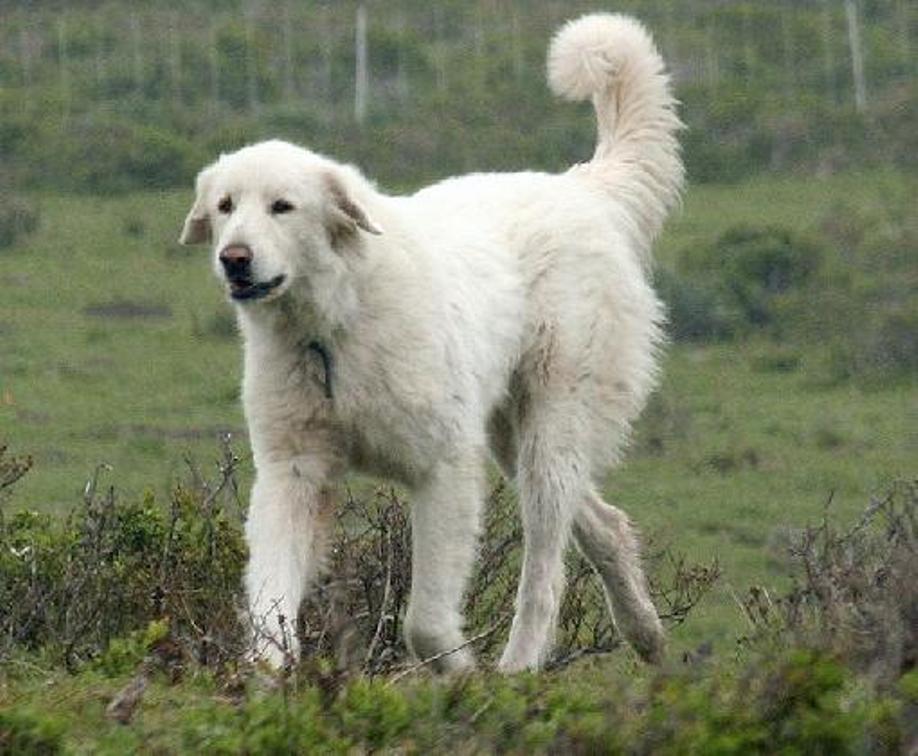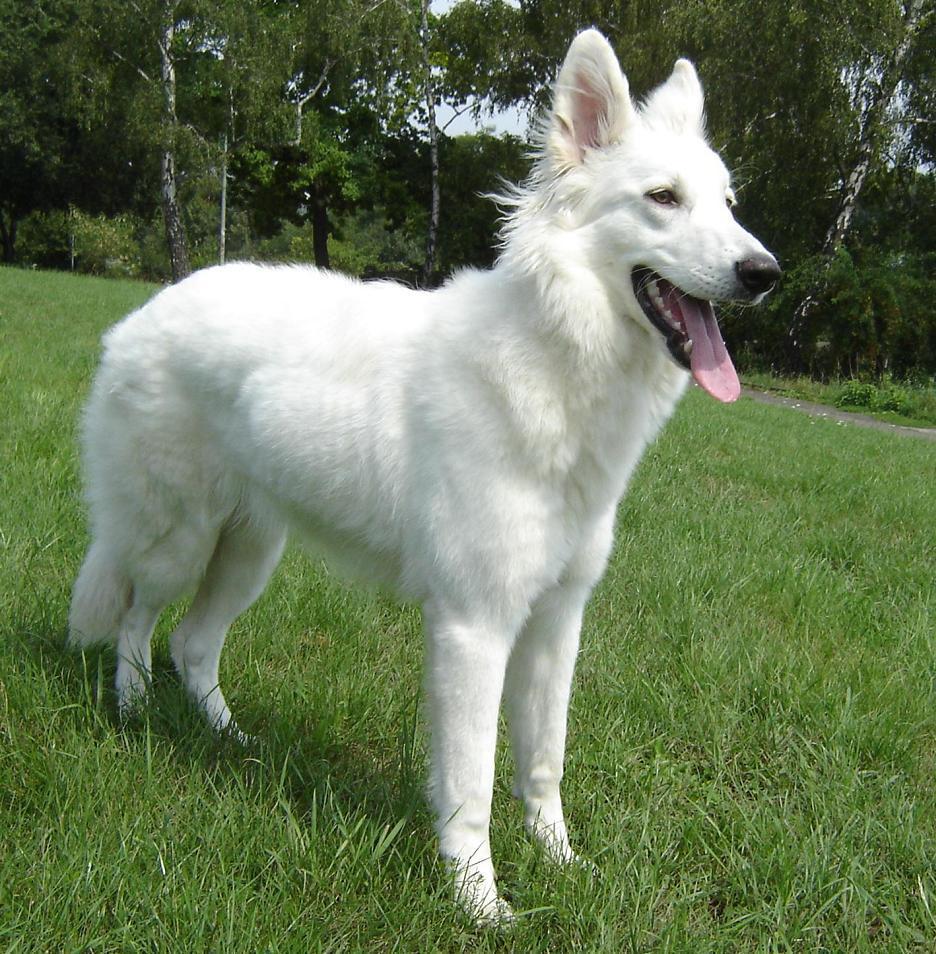The first image is the image on the left, the second image is the image on the right. For the images shown, is this caption "One of the dogs has its tongue visible." true? Answer yes or no. Yes. 